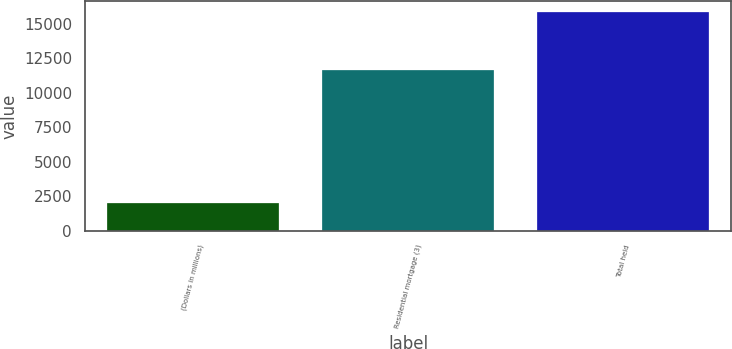<chart> <loc_0><loc_0><loc_500><loc_500><bar_chart><fcel>(Dollars in millions)<fcel>Residential mortgage (3)<fcel>Total held<nl><fcel>2009<fcel>11680<fcel>15829<nl></chart> 